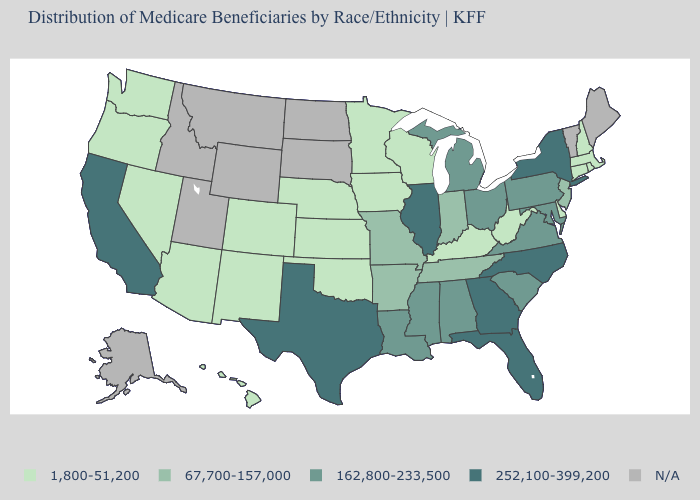Among the states that border Vermont , does New York have the highest value?
Quick response, please. Yes. Name the states that have a value in the range 1,800-51,200?
Write a very short answer. Arizona, Colorado, Connecticut, Delaware, Hawaii, Iowa, Kansas, Kentucky, Massachusetts, Minnesota, Nebraska, Nevada, New Hampshire, New Mexico, Oklahoma, Oregon, Rhode Island, Washington, West Virginia, Wisconsin. What is the value of North Carolina?
Be succinct. 252,100-399,200. What is the value of Maryland?
Be succinct. 162,800-233,500. What is the value of Vermont?
Give a very brief answer. N/A. Is the legend a continuous bar?
Be succinct. No. Among the states that border Alabama , does Mississippi have the highest value?
Concise answer only. No. What is the value of Kansas?
Keep it brief. 1,800-51,200. Name the states that have a value in the range 1,800-51,200?
Keep it brief. Arizona, Colorado, Connecticut, Delaware, Hawaii, Iowa, Kansas, Kentucky, Massachusetts, Minnesota, Nebraska, Nevada, New Hampshire, New Mexico, Oklahoma, Oregon, Rhode Island, Washington, West Virginia, Wisconsin. Does the map have missing data?
Give a very brief answer. Yes. Name the states that have a value in the range 252,100-399,200?
Short answer required. California, Florida, Georgia, Illinois, New York, North Carolina, Texas. What is the value of Missouri?
Write a very short answer. 67,700-157,000. Which states hav the highest value in the South?
Write a very short answer. Florida, Georgia, North Carolina, Texas. What is the value of North Carolina?
Write a very short answer. 252,100-399,200. Which states hav the highest value in the MidWest?
Answer briefly. Illinois. 